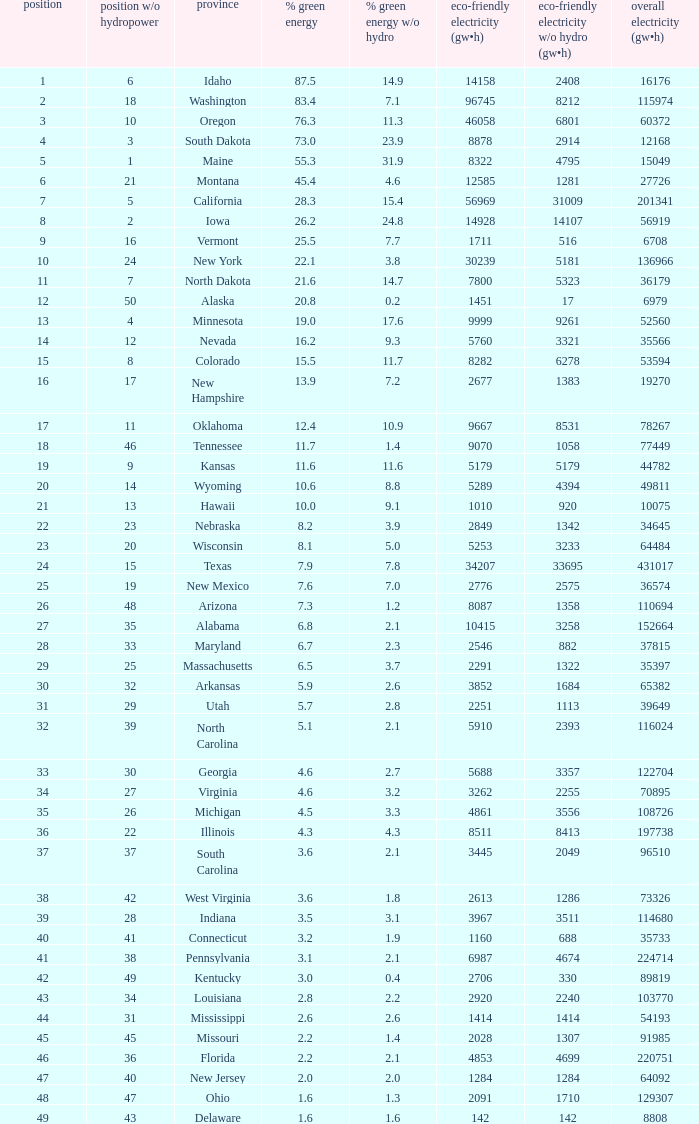When renewable electricity is 5760 (gw×h) what is the minimum amount of renewable elecrrixity without hydrogen power? 3321.0. 